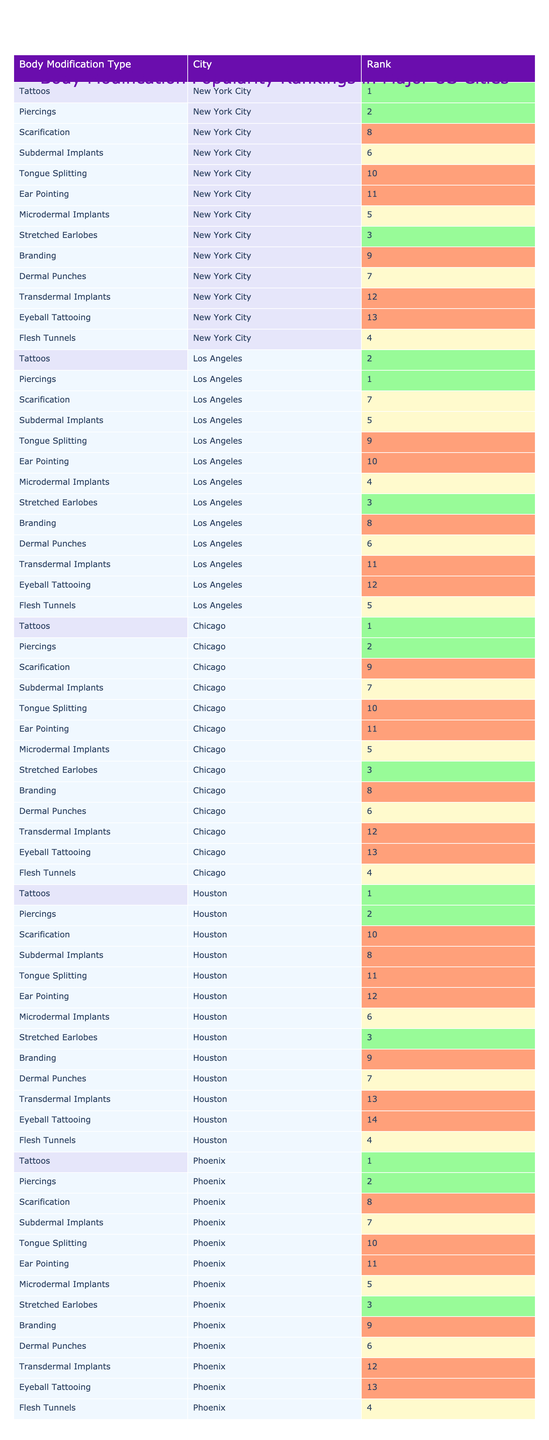What is the most popular body modification type in New York City? The table shows that Tattoos are ranked 1st in New York City, indicating they are the most popular body modification type there.
Answer: Tattoos Which body modification type has the highest ranking in Los Angeles? The table shows that Piercings are ranked 1st in Los Angeles, making them the highest ranking type in that city.
Answer: Piercings How many body modification types have a ranking of 3 or lower in Chicago? There are 3 types ranked 3 or lower: Tattoos (1), Piercings (2), and Stretched Earlobes (3).
Answer: 3 Is there a body modification type that is ranked 4th in all cities? By checking the rankings in the table, Flesh Tunnels is ranked 4th in New York City, Chicago, and Houston. This indicates it's not universally ranked across all cities.
Answer: No Which city ranks highest for Scarification? The table shows Scarification has a rank of 7 in Los Angeles, which is the best ranking compared to other cities listed.
Answer: Los Angeles What is the average rank of Subdermal Implants across all cities? The ranks for Subdermal Implants are 6 (NYC), 5 (LA), 7 (Chicago), 8 (Houston), and 7 (Phoenix). Summing these gives 33, so the average is 33/5 = 6.6.
Answer: 6.6 Which body modification type has the lowest overall ranking in Houston? According to the table, Tongue Splitting is ranked 11th in Houston, making it the least popular body modification type there.
Answer: Tongue Splitting What is the rank difference between Piercings in Los Angeles and Piercings in Chicago? In Los Angeles, Piercings are ranked 1st, while in Chicago they are ranked 2nd. The difference in rankings is 1.
Answer: 1 In how many cities is Ear Pointing ranked higher than Branding? Ear Pointing is ranked 11th in NYC and 10th in LA, while Branding is 9th in NYC and 8th in LA. Therefore, in all cities except Houston, where both are not ranked the same, Branding is always higher.
Answer: 0 Which city has a rank of 12 for Transdermal Implants? The table indicates that Transdermal Implants are ranked 12th in both New York City and Chicago.
Answer: New York City and Chicago 